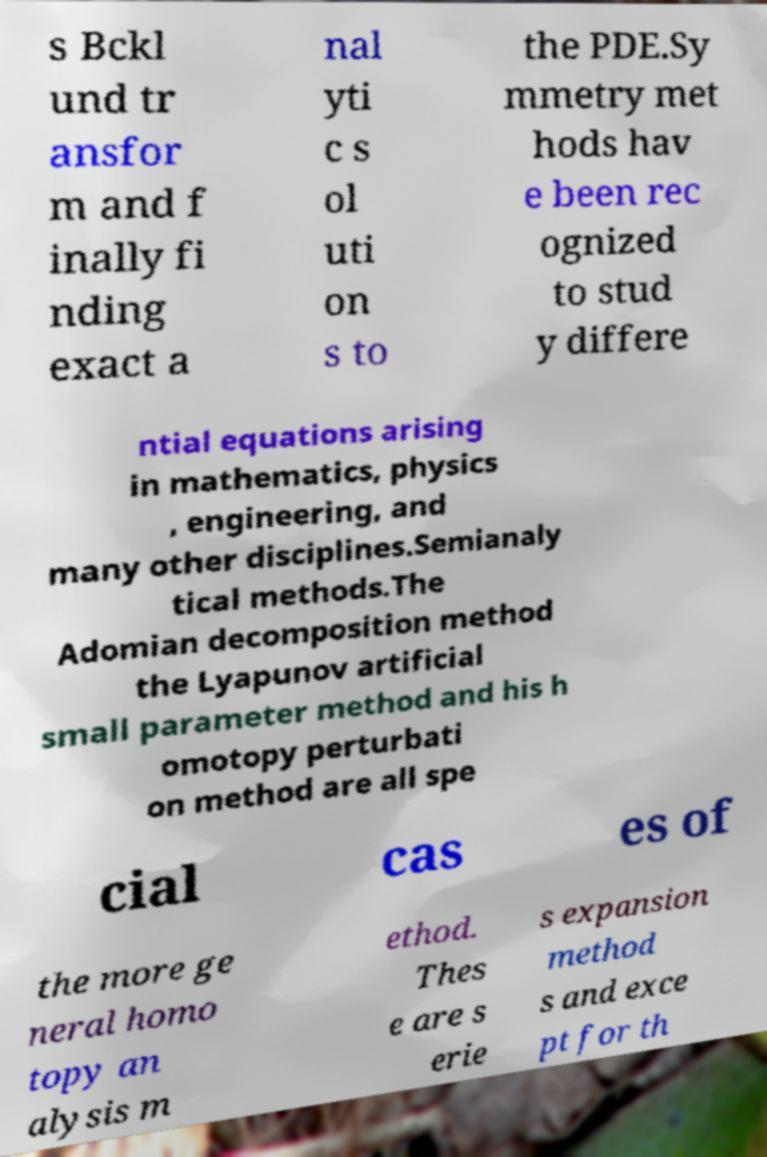Can you read and provide the text displayed in the image?This photo seems to have some interesting text. Can you extract and type it out for me? s Bckl und tr ansfor m and f inally fi nding exact a nal yti c s ol uti on s to the PDE.Sy mmetry met hods hav e been rec ognized to stud y differe ntial equations arising in mathematics, physics , engineering, and many other disciplines.Semianaly tical methods.The Adomian decomposition method the Lyapunov artificial small parameter method and his h omotopy perturbati on method are all spe cial cas es of the more ge neral homo topy an alysis m ethod. Thes e are s erie s expansion method s and exce pt for th 